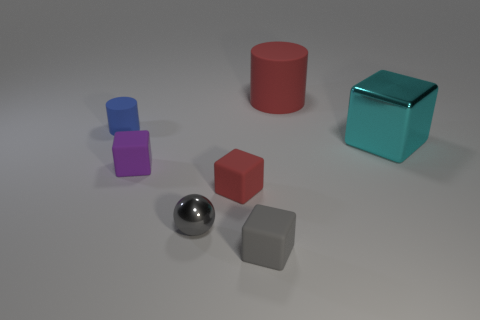Add 2 metal objects. How many objects exist? 9 Subtract all tiny gray blocks. How many blocks are left? 3 Subtract all red blocks. How many blocks are left? 3 Subtract 3 blocks. How many blocks are left? 1 Subtract all large red objects. Subtract all small gray matte cubes. How many objects are left? 5 Add 6 red cubes. How many red cubes are left? 7 Add 3 large purple shiny cylinders. How many large purple shiny cylinders exist? 3 Subtract 0 yellow cubes. How many objects are left? 7 Subtract all blocks. How many objects are left? 3 Subtract all purple blocks. Subtract all blue cylinders. How many blocks are left? 3 